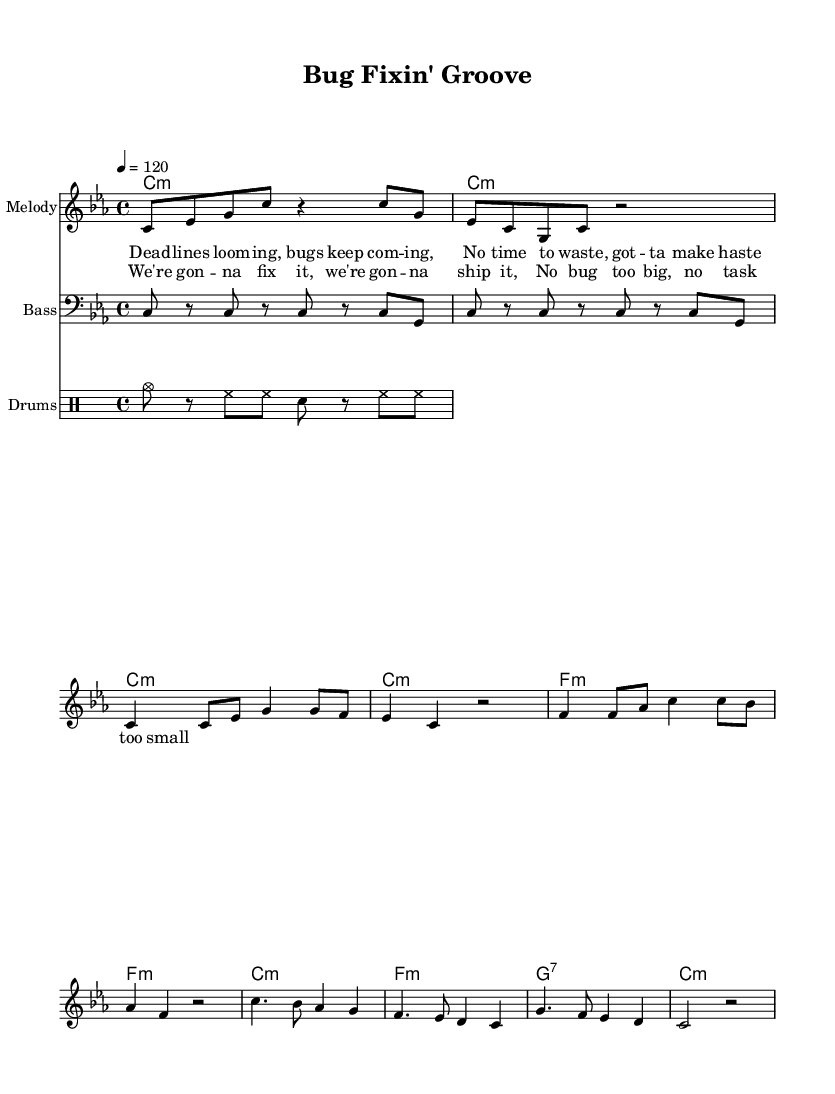What is the key signature of this music? The key signature is C minor, indicated by the flat symbols (B♭, E♭). This signature suggests that B♭ and E♭ are played flat throughout the piece.
Answer: C minor What is the time signature of this piece? The time signature shown in the music is 4/4, which is indicated by the "4/4" notation at the beginning. This means there are four beats in each measure, and the quarter note gets one beat.
Answer: 4/4 What is the tempo marking for this piece? The tempo marking indicates that the piece should be played at a speed of 120 beats per minute, as noted by "4 = 120" at the beginning of the score.
Answer: 120 How many measures are in the chorus section? The chorus section contains 4 measures, which can be counted by looking at the rhythmic structure of the music. Each line of lyrics corresponds to measures, and there are 4 lines in the chorus.
Answer: 4 What is the chord progression in the chorus? The chord progression in the chorus is C minor, F minor, G7, C minor. This can be deduced from analyzing the chords listed above the melody notes in the chorus section.
Answer: C minor, F minor, G7, C minor What style of rhythm is used in this funk piece? The rhythm used in this funk piece features a syncopated groove, evident in the rhythmic patterns of the melody and bass lines, typical of funk music that emphasizes off-beats.
Answer: Syncopated groove What is the main lyrical theme communicated in this piece? The main lyrical theme revolves around urgency, determination, and teamwork to resolve bugs and meet deadlines. This can be understood through the context of the lyrics in both the verse and chorus.
Answer: Urgency and teamwork 